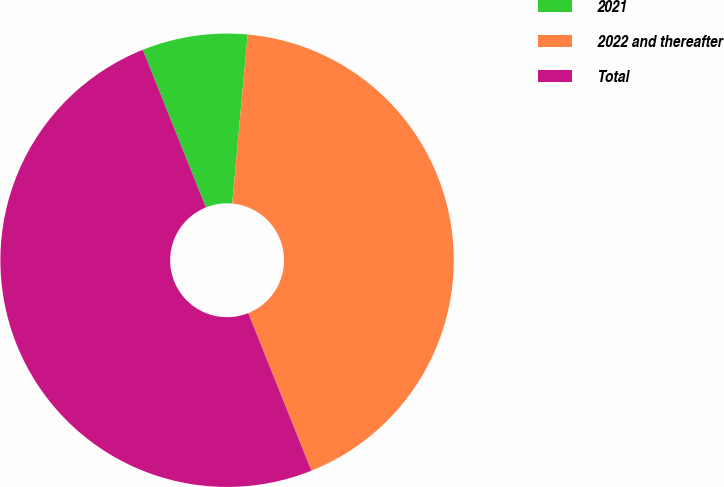<chart> <loc_0><loc_0><loc_500><loc_500><pie_chart><fcel>2021<fcel>2022 and thereafter<fcel>Total<nl><fcel>7.51%<fcel>42.49%<fcel>50.0%<nl></chart> 